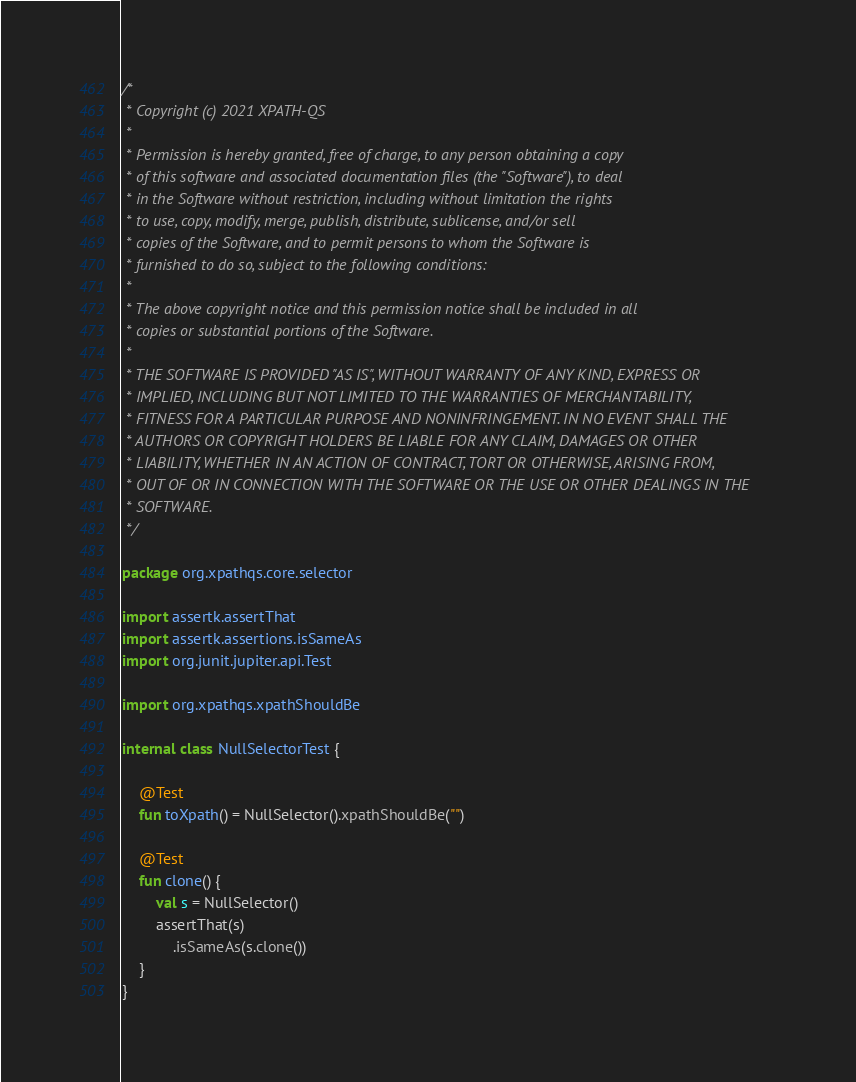Convert code to text. <code><loc_0><loc_0><loc_500><loc_500><_Kotlin_>/*
 * Copyright (c) 2021 XPATH-QS
 *
 * Permission is hereby granted, free of charge, to any person obtaining a copy
 * of this software and associated documentation files (the "Software"), to deal
 * in the Software without restriction, including without limitation the rights
 * to use, copy, modify, merge, publish, distribute, sublicense, and/or sell
 * copies of the Software, and to permit persons to whom the Software is
 * furnished to do so, subject to the following conditions:
 *
 * The above copyright notice and this permission notice shall be included in all
 * copies or substantial portions of the Software.
 *
 * THE SOFTWARE IS PROVIDED "AS IS", WITHOUT WARRANTY OF ANY KIND, EXPRESS OR
 * IMPLIED, INCLUDING BUT NOT LIMITED TO THE WARRANTIES OF MERCHANTABILITY,
 * FITNESS FOR A PARTICULAR PURPOSE AND NONINFRINGEMENT. IN NO EVENT SHALL THE
 * AUTHORS OR COPYRIGHT HOLDERS BE LIABLE FOR ANY CLAIM, DAMAGES OR OTHER
 * LIABILITY, WHETHER IN AN ACTION OF CONTRACT, TORT OR OTHERWISE, ARISING FROM,
 * OUT OF OR IN CONNECTION WITH THE SOFTWARE OR THE USE OR OTHER DEALINGS IN THE
 * SOFTWARE.
 */

package org.xpathqs.core.selector

import assertk.assertThat
import assertk.assertions.isSameAs
import org.junit.jupiter.api.Test

import org.xpathqs.xpathShouldBe

internal class NullSelectorTest {

    @Test
    fun toXpath() = NullSelector().xpathShouldBe("")

    @Test
    fun clone() {
        val s = NullSelector()
        assertThat(s)
            .isSameAs(s.clone())
    }
}</code> 